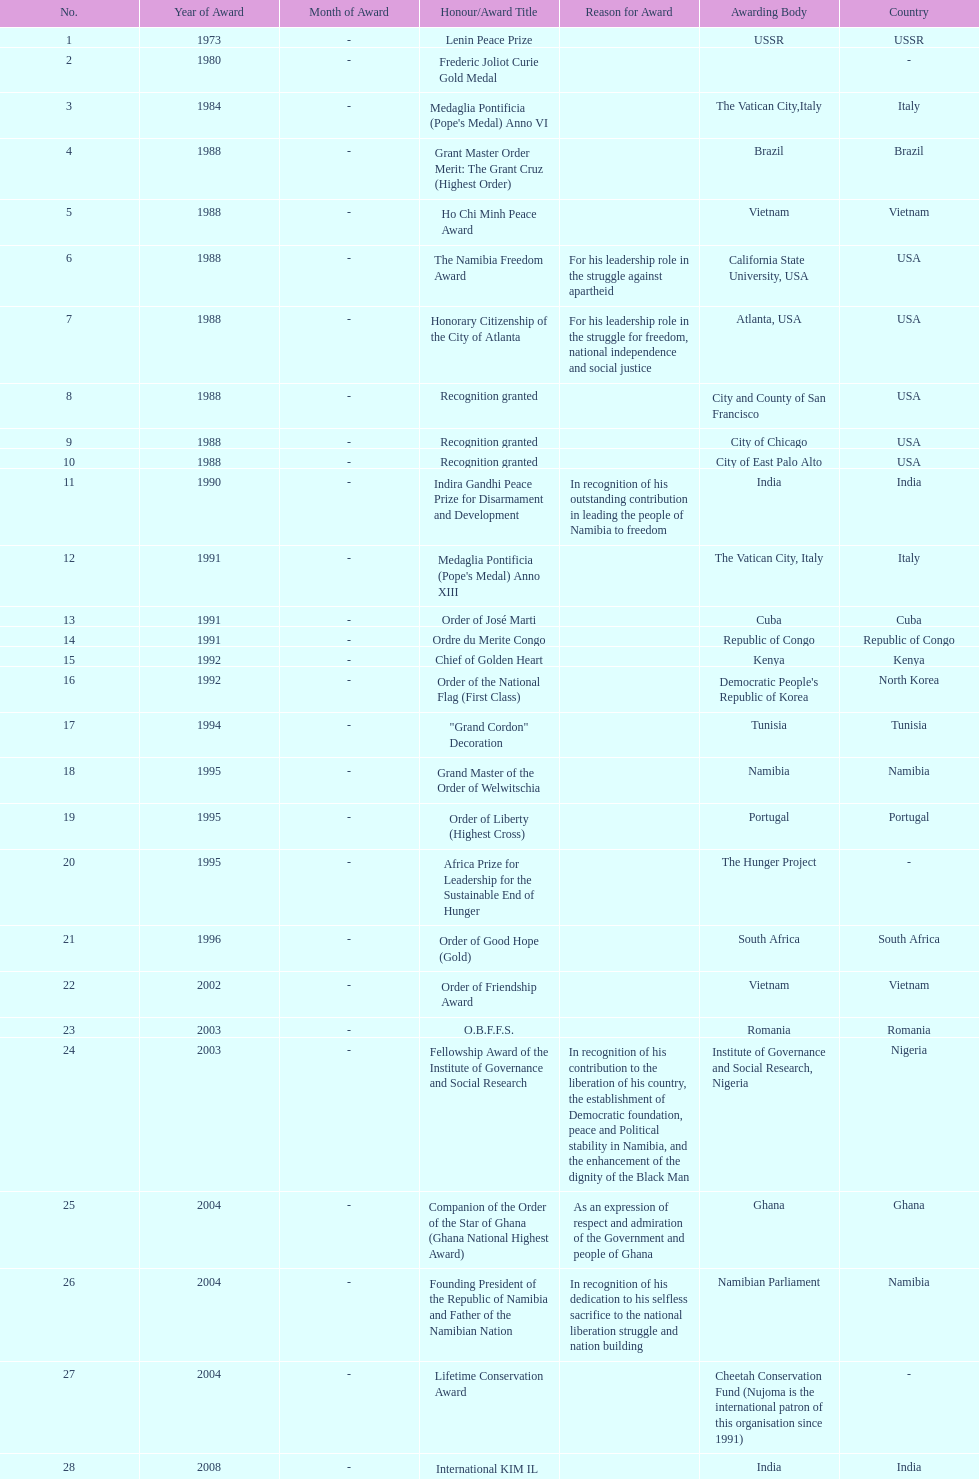What was the last award that nujoma won? Sir Seretse Khama SADC Meda. 